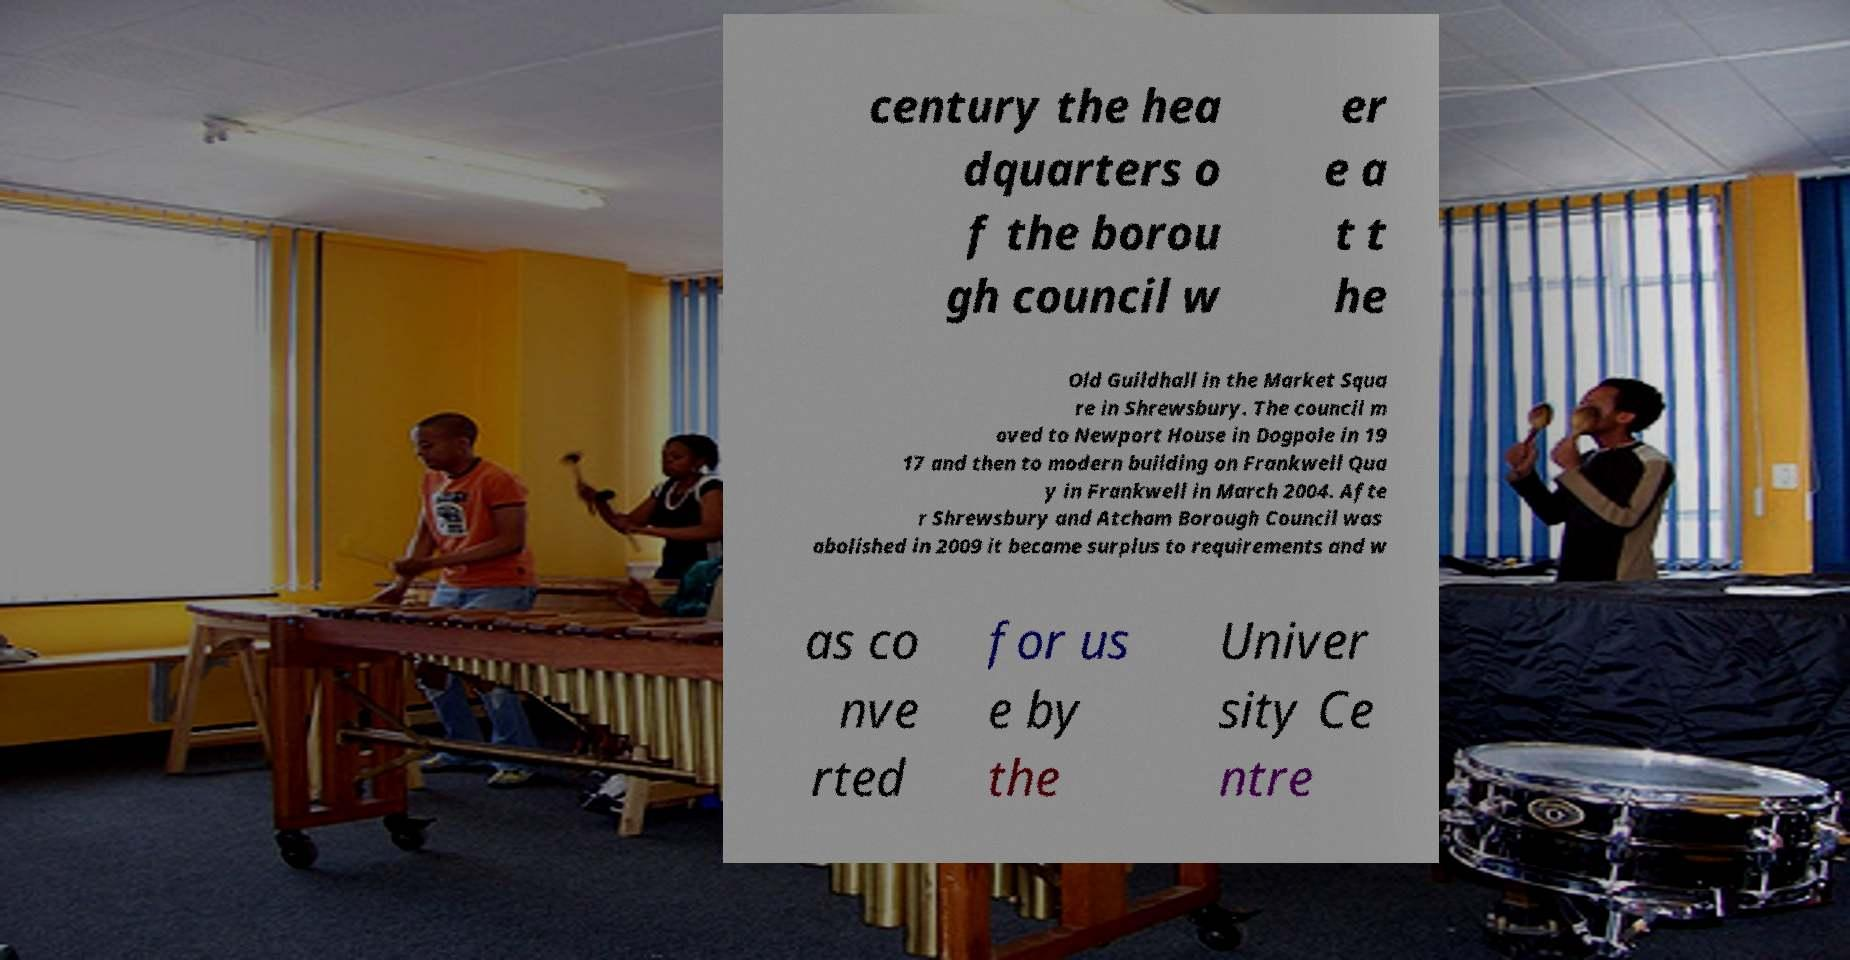Please identify and transcribe the text found in this image. century the hea dquarters o f the borou gh council w er e a t t he Old Guildhall in the Market Squa re in Shrewsbury. The council m oved to Newport House in Dogpole in 19 17 and then to modern building on Frankwell Qua y in Frankwell in March 2004. Afte r Shrewsbury and Atcham Borough Council was abolished in 2009 it became surplus to requirements and w as co nve rted for us e by the Univer sity Ce ntre 